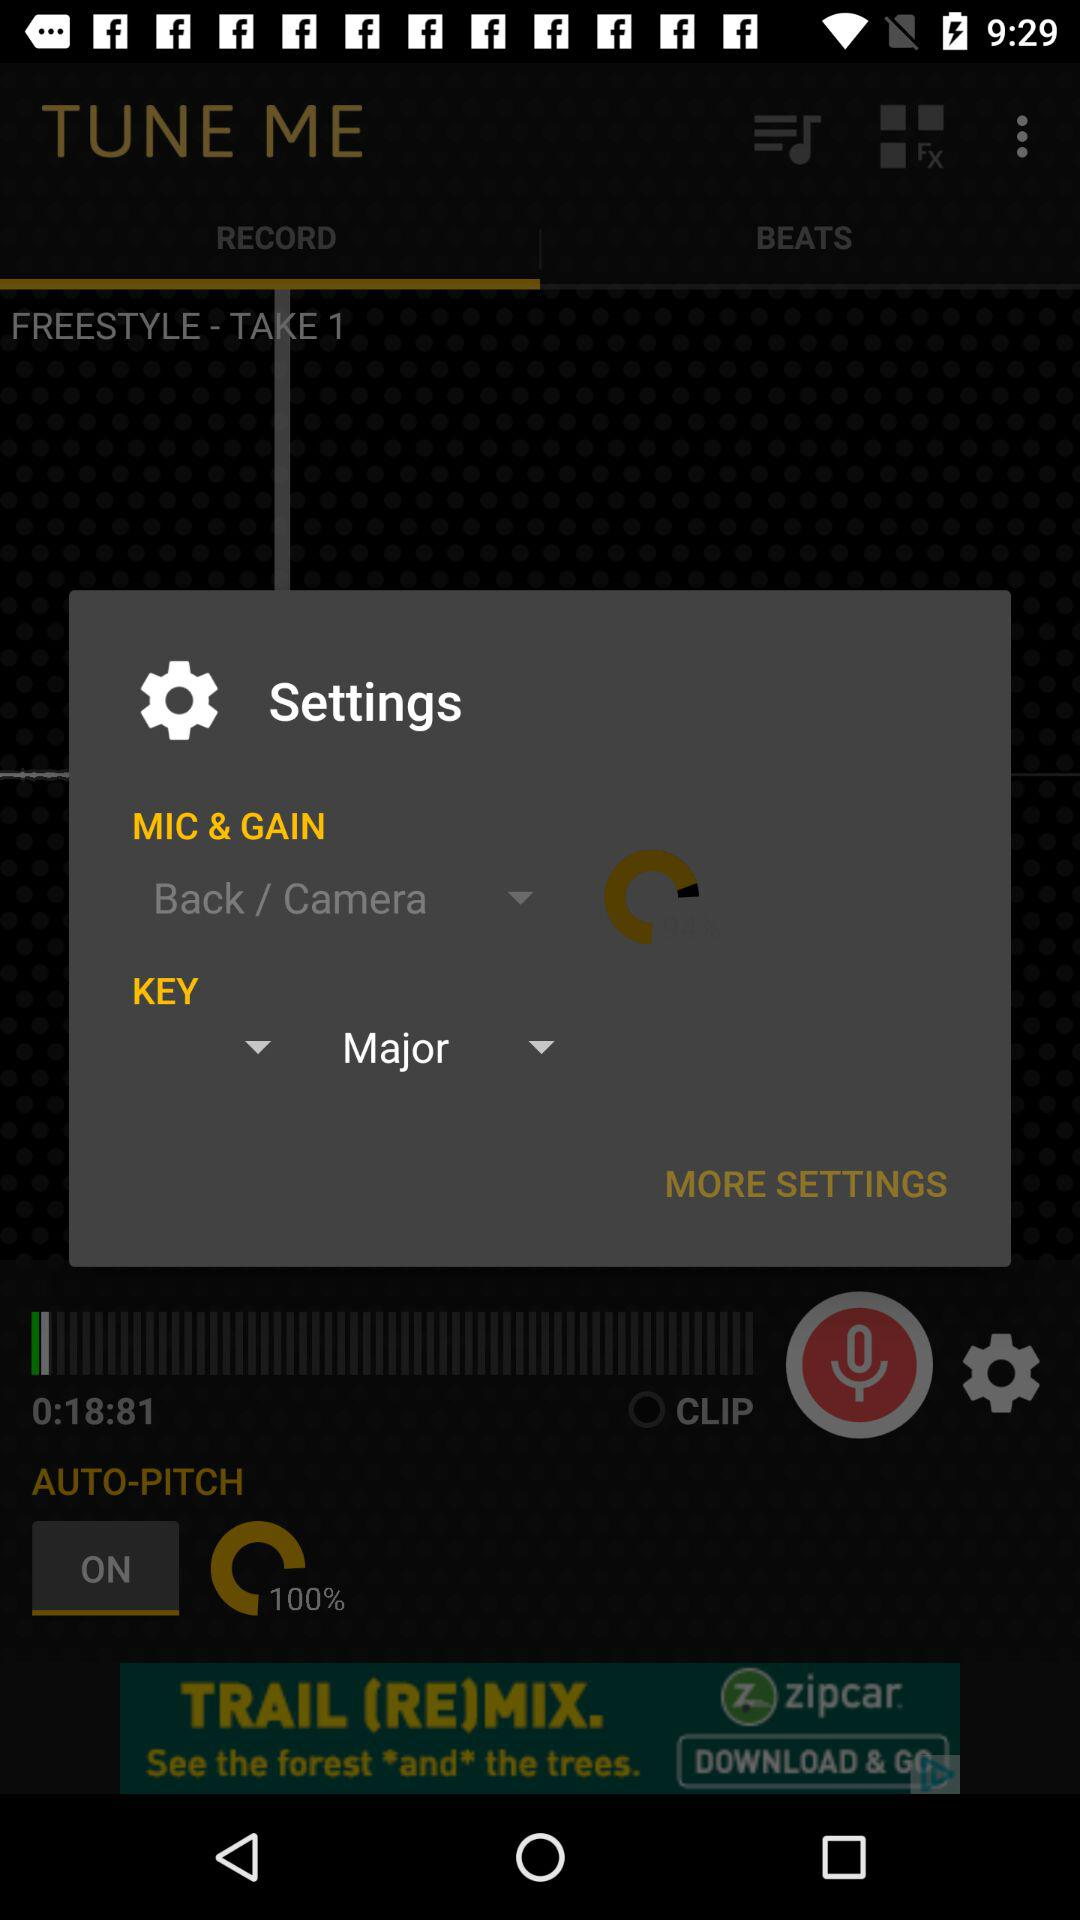Which option is selected in "MIC & GAIN"? The selected option in "MIC & GAIN" is "Back / Camera". 